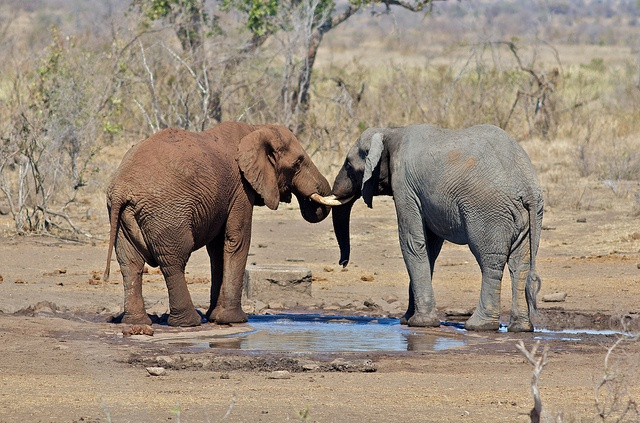Describe the objects in this image and their specific colors. I can see elephant in gray, black, brown, and tan tones and elephant in gray, darkgray, and black tones in this image. 